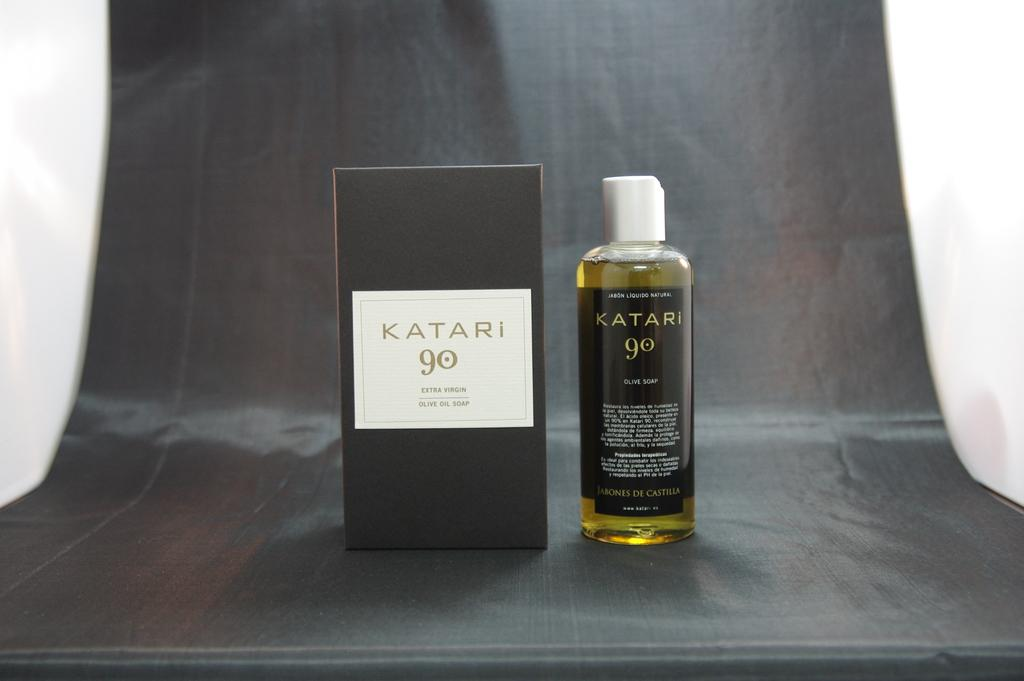<image>
Relay a brief, clear account of the picture shown. Bottle of Katari 90 next to the box of it. 